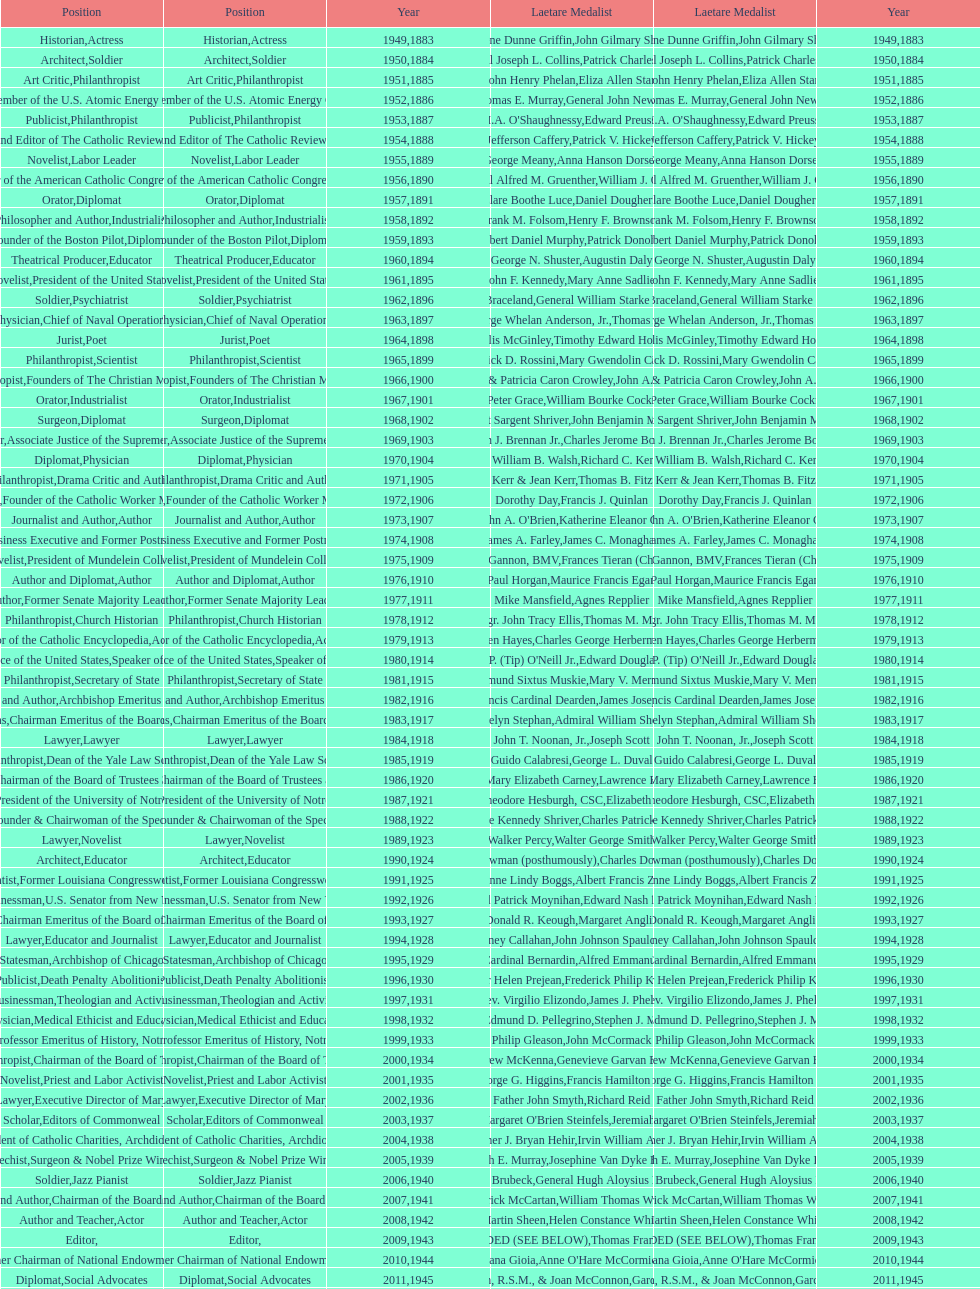How many laetare medal winners were charitable donors? 2. 